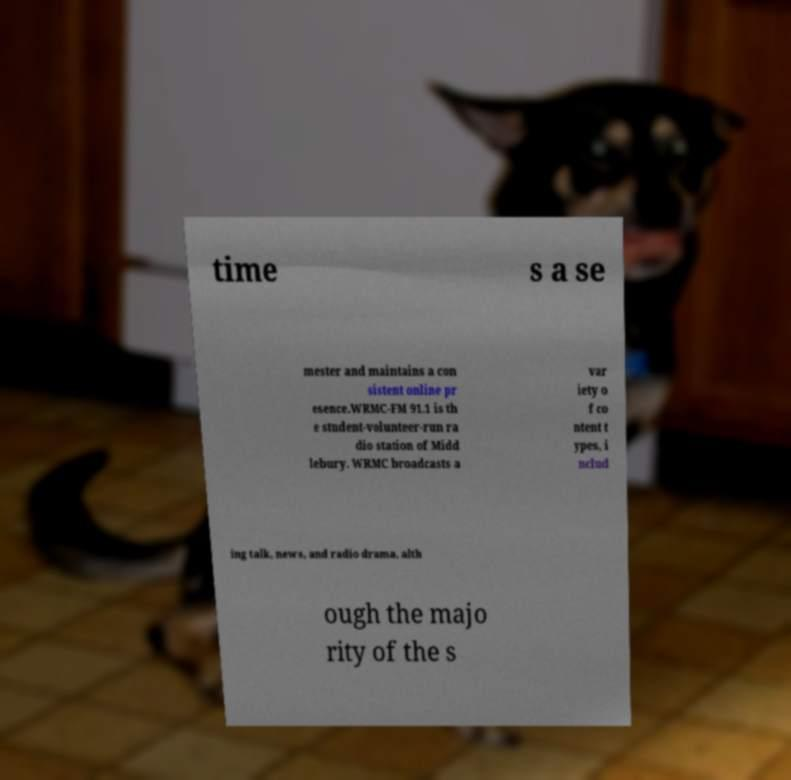What messages or text are displayed in this image? I need them in a readable, typed format. time s a se mester and maintains a con sistent online pr esence.WRMC-FM 91.1 is th e student-volunteer-run ra dio station of Midd lebury. WRMC broadcasts a var iety o f co ntent t ypes, i nclud ing talk, news, and radio drama, alth ough the majo rity of the s 